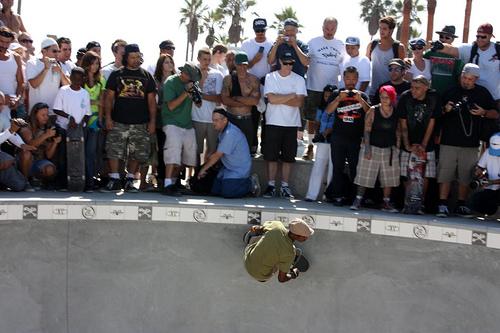How many people in white shirts?
Keep it brief. 13. Are there people taking photos?
Answer briefly. Yes. What is this person riding?
Keep it brief. Skateboard. 